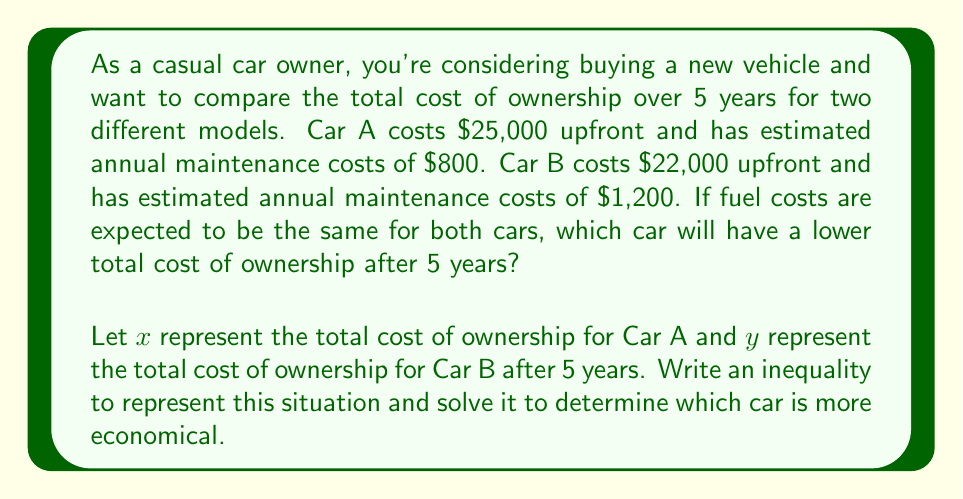Can you solve this math problem? To solve this problem, we need to set up inequalities representing the total cost of ownership for each car over 5 years.

For Car A:
$x = 25000 + (800 \times 5)$

For Car B:
$y = 22000 + (1200 \times 5)$

We want to determine which car has a lower total cost of ownership, so we'll set up the inequality:

$x < y$

Now, let's substitute the expressions for $x$ and $y$:

$25000 + (800 \times 5) < 22000 + (1200 \times 5)$

Simplify the multiplication:
$25000 + 4000 < 22000 + 6000$

Add the terms on each side:
$29000 < 28000$

This inequality is false, which means that the total cost of ownership for Car A is not less than Car B. Therefore, Car B has a lower total cost of ownership after 5 years.

To find the exact difference, we can subtract:
$28000 - 29000 = -1000$

This means Car B is $1000 cheaper over 5 years.
Answer: Car B has a lower total cost of ownership after 5 years, being $1000 cheaper than Car A. 